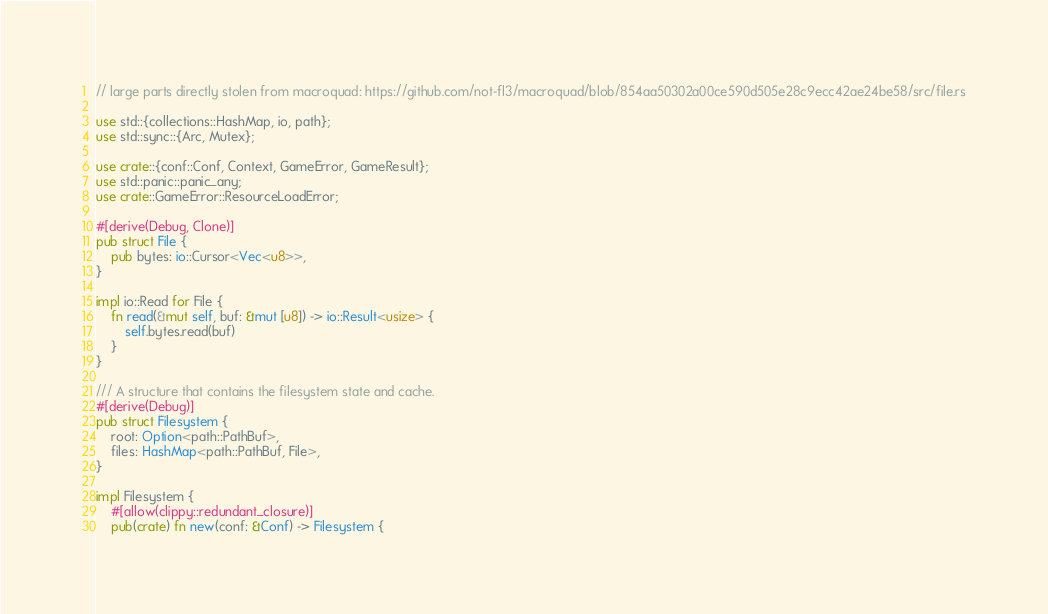Convert code to text. <code><loc_0><loc_0><loc_500><loc_500><_Rust_>// large parts directly stolen from macroquad: https://github.com/not-fl3/macroquad/blob/854aa50302a00ce590d505e28c9ecc42ae24be58/src/file.rs

use std::{collections::HashMap, io, path};
use std::sync::{Arc, Mutex};

use crate::{conf::Conf, Context, GameError, GameResult};
use std::panic::panic_any;
use crate::GameError::ResourceLoadError;

#[derive(Debug, Clone)]
pub struct File {
    pub bytes: io::Cursor<Vec<u8>>,
}

impl io::Read for File {
    fn read(&mut self, buf: &mut [u8]) -> io::Result<usize> {
        self.bytes.read(buf)
    }
}

/// A structure that contains the filesystem state and cache.
#[derive(Debug)]
pub struct Filesystem {
    root: Option<path::PathBuf>,
    files: HashMap<path::PathBuf, File>,
}

impl Filesystem {
    #[allow(clippy::redundant_closure)]
    pub(crate) fn new(conf: &Conf) -> Filesystem {</code> 